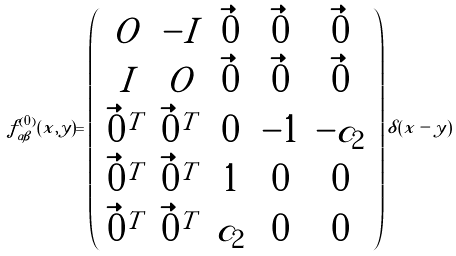<formula> <loc_0><loc_0><loc_500><loc_500>f ^ { ( 0 ) } _ { \alpha \beta } ( x , y ) = \left ( \begin{array} { c c c c c } O & - I & \vec { 0 } & \vec { 0 } & \vec { 0 } \\ I & O & \vec { 0 } & \vec { 0 } & \vec { 0 } \\ \vec { 0 } ^ { T } & \vec { 0 } ^ { T } & 0 & - 1 & - c _ { 2 } \\ \vec { 0 } ^ { T } & \vec { 0 } ^ { T } & 1 & 0 & 0 \\ \vec { 0 } ^ { T } & \vec { 0 } ^ { T } & c _ { 2 } & 0 & 0 \end{array} \right ) \delta ( x - y )</formula> 